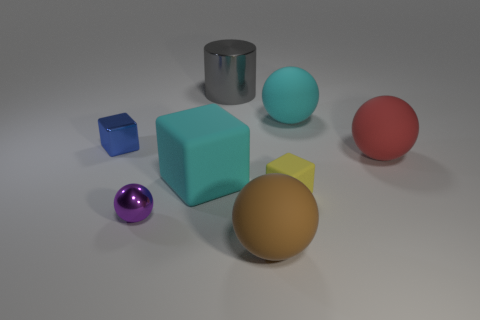Is there any other thing that has the same shape as the large gray shiny thing?
Keep it short and to the point. No. Does the block that is behind the large red rubber sphere have the same material as the big cyan thing that is behind the large cyan rubber cube?
Provide a short and direct response. No. What is the cylinder made of?
Ensure brevity in your answer.  Metal. What number of tiny purple spheres are made of the same material as the small blue thing?
Your answer should be very brief. 1. What number of rubber things are either tiny spheres or large cylinders?
Offer a very short reply. 0. There is a cyan thing to the right of the cyan block; is it the same shape as the metallic thing in front of the large red sphere?
Your answer should be very brief. Yes. There is a metallic object that is behind the large cube and in front of the big gray cylinder; what color is it?
Your answer should be very brief. Blue. There is a object that is to the left of the tiny purple shiny thing; is its size the same as the metal object in front of the small yellow matte cube?
Your response must be concise. Yes. How many large things have the same color as the large matte cube?
Offer a terse response. 1. How many big things are red metallic objects or blue objects?
Offer a terse response. 0. 